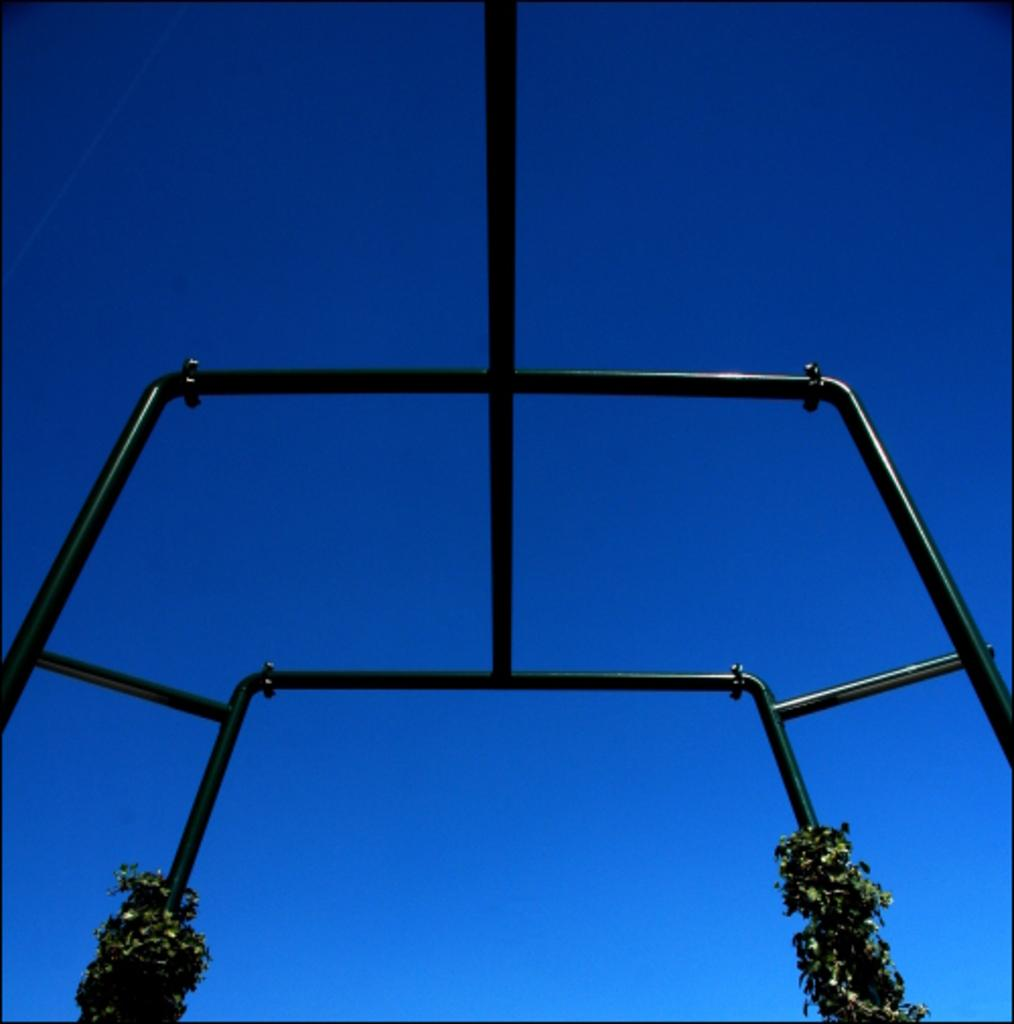What objects are present in the image that have a black color? There are black rods in the image. What other elements can be seen near the black rods? There are plants near the black rods. What color is the area behind the black rods? The area behind the black rods is blue in color. What type of jam is being spread on the grapes in the image? There are no jams or grapes present in the image; it only features black rods and plants. Is there a garden visible in the image? The image does not show a garden; it only features black rods, plants, and a blue area. 